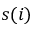<formula> <loc_0><loc_0><loc_500><loc_500>s ( i )</formula> 